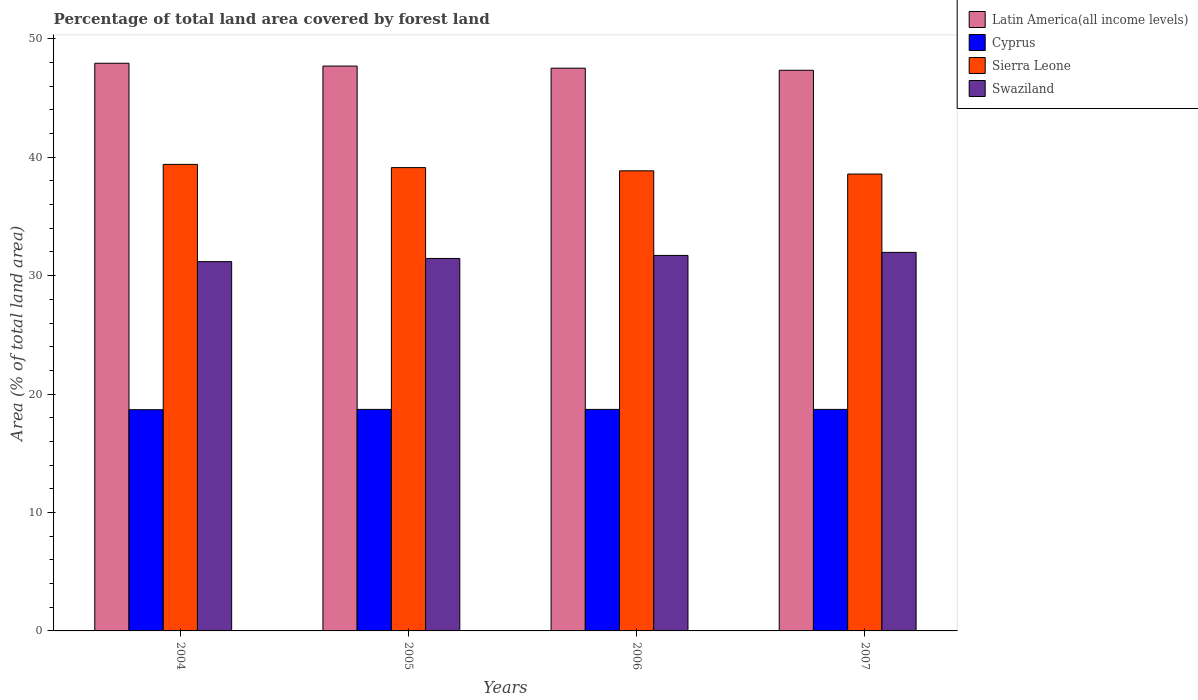How many different coloured bars are there?
Provide a short and direct response. 4. Are the number of bars per tick equal to the number of legend labels?
Ensure brevity in your answer.  Yes. What is the label of the 4th group of bars from the left?
Keep it short and to the point. 2007. In how many cases, is the number of bars for a given year not equal to the number of legend labels?
Your answer should be very brief. 0. What is the percentage of forest land in Swaziland in 2007?
Give a very brief answer. 31.97. Across all years, what is the maximum percentage of forest land in Sierra Leone?
Keep it short and to the point. 39.4. Across all years, what is the minimum percentage of forest land in Sierra Leone?
Your response must be concise. 38.58. What is the total percentage of forest land in Swaziland in the graph?
Your answer should be compact. 126.31. What is the difference between the percentage of forest land in Sierra Leone in 2005 and that in 2006?
Give a very brief answer. 0.27. What is the difference between the percentage of forest land in Sierra Leone in 2007 and the percentage of forest land in Latin America(all income levels) in 2004?
Provide a succinct answer. -9.35. What is the average percentage of forest land in Latin America(all income levels) per year?
Make the answer very short. 47.62. In the year 2005, what is the difference between the percentage of forest land in Swaziland and percentage of forest land in Latin America(all income levels)?
Provide a short and direct response. -16.24. What is the ratio of the percentage of forest land in Latin America(all income levels) in 2004 to that in 2006?
Provide a short and direct response. 1.01. Is the difference between the percentage of forest land in Swaziland in 2006 and 2007 greater than the difference between the percentage of forest land in Latin America(all income levels) in 2006 and 2007?
Provide a succinct answer. No. What is the difference between the highest and the second highest percentage of forest land in Sierra Leone?
Ensure brevity in your answer.  0.27. What is the difference between the highest and the lowest percentage of forest land in Cyprus?
Offer a very short reply. 0.03. Is the sum of the percentage of forest land in Sierra Leone in 2005 and 2007 greater than the maximum percentage of forest land in Cyprus across all years?
Give a very brief answer. Yes. What does the 3rd bar from the left in 2005 represents?
Make the answer very short. Sierra Leone. What does the 2nd bar from the right in 2007 represents?
Your answer should be very brief. Sierra Leone. How many bars are there?
Ensure brevity in your answer.  16. What is the difference between two consecutive major ticks on the Y-axis?
Offer a very short reply. 10. Are the values on the major ticks of Y-axis written in scientific E-notation?
Offer a terse response. No. Does the graph contain any zero values?
Your answer should be very brief. No. Does the graph contain grids?
Give a very brief answer. No. Where does the legend appear in the graph?
Make the answer very short. Top right. What is the title of the graph?
Offer a terse response. Percentage of total land area covered by forest land. What is the label or title of the Y-axis?
Your response must be concise. Area (% of total land area). What is the Area (% of total land area) of Latin America(all income levels) in 2004?
Your answer should be compact. 47.94. What is the Area (% of total land area) in Cyprus in 2004?
Provide a short and direct response. 18.68. What is the Area (% of total land area) of Sierra Leone in 2004?
Make the answer very short. 39.4. What is the Area (% of total land area) of Swaziland in 2004?
Provide a succinct answer. 31.19. What is the Area (% of total land area) of Latin America(all income levels) in 2005?
Make the answer very short. 47.7. What is the Area (% of total land area) of Cyprus in 2005?
Keep it short and to the point. 18.71. What is the Area (% of total land area) of Sierra Leone in 2005?
Offer a terse response. 39.12. What is the Area (% of total land area) of Swaziland in 2005?
Offer a very short reply. 31.45. What is the Area (% of total land area) of Latin America(all income levels) in 2006?
Your answer should be compact. 47.52. What is the Area (% of total land area) in Cyprus in 2006?
Provide a succinct answer. 18.71. What is the Area (% of total land area) of Sierra Leone in 2006?
Keep it short and to the point. 38.85. What is the Area (% of total land area) of Swaziland in 2006?
Your answer should be compact. 31.71. What is the Area (% of total land area) in Latin America(all income levels) in 2007?
Provide a succinct answer. 47.34. What is the Area (% of total land area) in Cyprus in 2007?
Your answer should be compact. 18.71. What is the Area (% of total land area) of Sierra Leone in 2007?
Keep it short and to the point. 38.58. What is the Area (% of total land area) of Swaziland in 2007?
Your answer should be compact. 31.97. Across all years, what is the maximum Area (% of total land area) in Latin America(all income levels)?
Make the answer very short. 47.94. Across all years, what is the maximum Area (% of total land area) of Cyprus?
Your answer should be very brief. 18.71. Across all years, what is the maximum Area (% of total land area) in Sierra Leone?
Your answer should be very brief. 39.4. Across all years, what is the maximum Area (% of total land area) in Swaziland?
Give a very brief answer. 31.97. Across all years, what is the minimum Area (% of total land area) in Latin America(all income levels)?
Your answer should be very brief. 47.34. Across all years, what is the minimum Area (% of total land area) in Cyprus?
Provide a succinct answer. 18.68. Across all years, what is the minimum Area (% of total land area) in Sierra Leone?
Your response must be concise. 38.58. Across all years, what is the minimum Area (% of total land area) of Swaziland?
Provide a short and direct response. 31.19. What is the total Area (% of total land area) of Latin America(all income levels) in the graph?
Give a very brief answer. 190.5. What is the total Area (% of total land area) in Cyprus in the graph?
Ensure brevity in your answer.  74.8. What is the total Area (% of total land area) in Sierra Leone in the graph?
Make the answer very short. 155.95. What is the total Area (% of total land area) of Swaziland in the graph?
Your answer should be very brief. 126.31. What is the difference between the Area (% of total land area) in Latin America(all income levels) in 2004 and that in 2005?
Keep it short and to the point. 0.24. What is the difference between the Area (% of total land area) in Cyprus in 2004 and that in 2005?
Your answer should be compact. -0.03. What is the difference between the Area (% of total land area) of Sierra Leone in 2004 and that in 2005?
Your answer should be very brief. 0.27. What is the difference between the Area (% of total land area) in Swaziland in 2004 and that in 2005?
Your response must be concise. -0.27. What is the difference between the Area (% of total land area) in Latin America(all income levels) in 2004 and that in 2006?
Make the answer very short. 0.42. What is the difference between the Area (% of total land area) in Cyprus in 2004 and that in 2006?
Your response must be concise. -0.03. What is the difference between the Area (% of total land area) in Sierra Leone in 2004 and that in 2006?
Provide a short and direct response. 0.54. What is the difference between the Area (% of total land area) of Swaziland in 2004 and that in 2006?
Keep it short and to the point. -0.52. What is the difference between the Area (% of total land area) of Latin America(all income levels) in 2004 and that in 2007?
Your answer should be very brief. 0.59. What is the difference between the Area (% of total land area) of Cyprus in 2004 and that in 2007?
Give a very brief answer. -0.03. What is the difference between the Area (% of total land area) in Sierra Leone in 2004 and that in 2007?
Provide a succinct answer. 0.81. What is the difference between the Area (% of total land area) in Swaziland in 2004 and that in 2007?
Provide a short and direct response. -0.78. What is the difference between the Area (% of total land area) in Latin America(all income levels) in 2005 and that in 2006?
Ensure brevity in your answer.  0.18. What is the difference between the Area (% of total land area) in Cyprus in 2005 and that in 2006?
Give a very brief answer. 0. What is the difference between the Area (% of total land area) of Sierra Leone in 2005 and that in 2006?
Offer a terse response. 0.27. What is the difference between the Area (% of total land area) in Swaziland in 2005 and that in 2006?
Offer a terse response. -0.26. What is the difference between the Area (% of total land area) in Latin America(all income levels) in 2005 and that in 2007?
Keep it short and to the point. 0.36. What is the difference between the Area (% of total land area) in Cyprus in 2005 and that in 2007?
Provide a short and direct response. 0. What is the difference between the Area (% of total land area) in Sierra Leone in 2005 and that in 2007?
Offer a very short reply. 0.54. What is the difference between the Area (% of total land area) of Swaziland in 2005 and that in 2007?
Ensure brevity in your answer.  -0.51. What is the difference between the Area (% of total land area) in Latin America(all income levels) in 2006 and that in 2007?
Provide a succinct answer. 0.18. What is the difference between the Area (% of total land area) in Cyprus in 2006 and that in 2007?
Provide a succinct answer. 0. What is the difference between the Area (% of total land area) of Sierra Leone in 2006 and that in 2007?
Your response must be concise. 0.27. What is the difference between the Area (% of total land area) in Swaziland in 2006 and that in 2007?
Offer a terse response. -0.26. What is the difference between the Area (% of total land area) of Latin America(all income levels) in 2004 and the Area (% of total land area) of Cyprus in 2005?
Provide a succinct answer. 29.23. What is the difference between the Area (% of total land area) in Latin America(all income levels) in 2004 and the Area (% of total land area) in Sierra Leone in 2005?
Your answer should be very brief. 8.81. What is the difference between the Area (% of total land area) in Latin America(all income levels) in 2004 and the Area (% of total land area) in Swaziland in 2005?
Your answer should be compact. 16.48. What is the difference between the Area (% of total land area) in Cyprus in 2004 and the Area (% of total land area) in Sierra Leone in 2005?
Offer a terse response. -20.44. What is the difference between the Area (% of total land area) of Cyprus in 2004 and the Area (% of total land area) of Swaziland in 2005?
Provide a succinct answer. -12.77. What is the difference between the Area (% of total land area) in Sierra Leone in 2004 and the Area (% of total land area) in Swaziland in 2005?
Offer a terse response. 7.94. What is the difference between the Area (% of total land area) of Latin America(all income levels) in 2004 and the Area (% of total land area) of Cyprus in 2006?
Offer a terse response. 29.23. What is the difference between the Area (% of total land area) of Latin America(all income levels) in 2004 and the Area (% of total land area) of Sierra Leone in 2006?
Provide a short and direct response. 9.08. What is the difference between the Area (% of total land area) of Latin America(all income levels) in 2004 and the Area (% of total land area) of Swaziland in 2006?
Offer a very short reply. 16.23. What is the difference between the Area (% of total land area) of Cyprus in 2004 and the Area (% of total land area) of Sierra Leone in 2006?
Your response must be concise. -20.17. What is the difference between the Area (% of total land area) of Cyprus in 2004 and the Area (% of total land area) of Swaziland in 2006?
Ensure brevity in your answer.  -13.03. What is the difference between the Area (% of total land area) in Sierra Leone in 2004 and the Area (% of total land area) in Swaziland in 2006?
Your answer should be compact. 7.69. What is the difference between the Area (% of total land area) in Latin America(all income levels) in 2004 and the Area (% of total land area) in Cyprus in 2007?
Your response must be concise. 29.23. What is the difference between the Area (% of total land area) in Latin America(all income levels) in 2004 and the Area (% of total land area) in Sierra Leone in 2007?
Your answer should be very brief. 9.35. What is the difference between the Area (% of total land area) in Latin America(all income levels) in 2004 and the Area (% of total land area) in Swaziland in 2007?
Your response must be concise. 15.97. What is the difference between the Area (% of total land area) in Cyprus in 2004 and the Area (% of total land area) in Sierra Leone in 2007?
Provide a succinct answer. -19.9. What is the difference between the Area (% of total land area) of Cyprus in 2004 and the Area (% of total land area) of Swaziland in 2007?
Your answer should be compact. -13.29. What is the difference between the Area (% of total land area) of Sierra Leone in 2004 and the Area (% of total land area) of Swaziland in 2007?
Your answer should be compact. 7.43. What is the difference between the Area (% of total land area) of Latin America(all income levels) in 2005 and the Area (% of total land area) of Cyprus in 2006?
Provide a succinct answer. 28.99. What is the difference between the Area (% of total land area) in Latin America(all income levels) in 2005 and the Area (% of total land area) in Sierra Leone in 2006?
Your answer should be very brief. 8.85. What is the difference between the Area (% of total land area) of Latin America(all income levels) in 2005 and the Area (% of total land area) of Swaziland in 2006?
Give a very brief answer. 15.99. What is the difference between the Area (% of total land area) of Cyprus in 2005 and the Area (% of total land area) of Sierra Leone in 2006?
Offer a very short reply. -20.15. What is the difference between the Area (% of total land area) of Cyprus in 2005 and the Area (% of total land area) of Swaziland in 2006?
Provide a succinct answer. -13. What is the difference between the Area (% of total land area) of Sierra Leone in 2005 and the Area (% of total land area) of Swaziland in 2006?
Provide a short and direct response. 7.42. What is the difference between the Area (% of total land area) of Latin America(all income levels) in 2005 and the Area (% of total land area) of Cyprus in 2007?
Your answer should be very brief. 28.99. What is the difference between the Area (% of total land area) of Latin America(all income levels) in 2005 and the Area (% of total land area) of Sierra Leone in 2007?
Make the answer very short. 9.12. What is the difference between the Area (% of total land area) of Latin America(all income levels) in 2005 and the Area (% of total land area) of Swaziland in 2007?
Your answer should be compact. 15.73. What is the difference between the Area (% of total land area) in Cyprus in 2005 and the Area (% of total land area) in Sierra Leone in 2007?
Make the answer very short. -19.87. What is the difference between the Area (% of total land area) of Cyprus in 2005 and the Area (% of total land area) of Swaziland in 2007?
Offer a very short reply. -13.26. What is the difference between the Area (% of total land area) in Sierra Leone in 2005 and the Area (% of total land area) in Swaziland in 2007?
Make the answer very short. 7.16. What is the difference between the Area (% of total land area) in Latin America(all income levels) in 2006 and the Area (% of total land area) in Cyprus in 2007?
Your answer should be very brief. 28.81. What is the difference between the Area (% of total land area) of Latin America(all income levels) in 2006 and the Area (% of total land area) of Sierra Leone in 2007?
Make the answer very short. 8.94. What is the difference between the Area (% of total land area) of Latin America(all income levels) in 2006 and the Area (% of total land area) of Swaziland in 2007?
Give a very brief answer. 15.56. What is the difference between the Area (% of total land area) of Cyprus in 2006 and the Area (% of total land area) of Sierra Leone in 2007?
Make the answer very short. -19.87. What is the difference between the Area (% of total land area) of Cyprus in 2006 and the Area (% of total land area) of Swaziland in 2007?
Offer a very short reply. -13.26. What is the difference between the Area (% of total land area) of Sierra Leone in 2006 and the Area (% of total land area) of Swaziland in 2007?
Keep it short and to the point. 6.89. What is the average Area (% of total land area) in Latin America(all income levels) per year?
Provide a short and direct response. 47.62. What is the average Area (% of total land area) of Cyprus per year?
Give a very brief answer. 18.7. What is the average Area (% of total land area) in Sierra Leone per year?
Keep it short and to the point. 38.99. What is the average Area (% of total land area) in Swaziland per year?
Provide a short and direct response. 31.58. In the year 2004, what is the difference between the Area (% of total land area) of Latin America(all income levels) and Area (% of total land area) of Cyprus?
Make the answer very short. 29.26. In the year 2004, what is the difference between the Area (% of total land area) in Latin America(all income levels) and Area (% of total land area) in Sierra Leone?
Your answer should be very brief. 8.54. In the year 2004, what is the difference between the Area (% of total land area) of Latin America(all income levels) and Area (% of total land area) of Swaziland?
Your answer should be very brief. 16.75. In the year 2004, what is the difference between the Area (% of total land area) of Cyprus and Area (% of total land area) of Sierra Leone?
Your answer should be compact. -20.72. In the year 2004, what is the difference between the Area (% of total land area) in Cyprus and Area (% of total land area) in Swaziland?
Your answer should be very brief. -12.51. In the year 2004, what is the difference between the Area (% of total land area) of Sierra Leone and Area (% of total land area) of Swaziland?
Provide a short and direct response. 8.21. In the year 2005, what is the difference between the Area (% of total land area) of Latin America(all income levels) and Area (% of total land area) of Cyprus?
Your answer should be very brief. 28.99. In the year 2005, what is the difference between the Area (% of total land area) of Latin America(all income levels) and Area (% of total land area) of Sierra Leone?
Offer a terse response. 8.57. In the year 2005, what is the difference between the Area (% of total land area) in Latin America(all income levels) and Area (% of total land area) in Swaziland?
Provide a succinct answer. 16.24. In the year 2005, what is the difference between the Area (% of total land area) in Cyprus and Area (% of total land area) in Sierra Leone?
Keep it short and to the point. -20.42. In the year 2005, what is the difference between the Area (% of total land area) of Cyprus and Area (% of total land area) of Swaziland?
Your response must be concise. -12.75. In the year 2005, what is the difference between the Area (% of total land area) of Sierra Leone and Area (% of total land area) of Swaziland?
Give a very brief answer. 7.67. In the year 2006, what is the difference between the Area (% of total land area) of Latin America(all income levels) and Area (% of total land area) of Cyprus?
Your answer should be very brief. 28.81. In the year 2006, what is the difference between the Area (% of total land area) of Latin America(all income levels) and Area (% of total land area) of Sierra Leone?
Make the answer very short. 8.67. In the year 2006, what is the difference between the Area (% of total land area) of Latin America(all income levels) and Area (% of total land area) of Swaziland?
Keep it short and to the point. 15.81. In the year 2006, what is the difference between the Area (% of total land area) in Cyprus and Area (% of total land area) in Sierra Leone?
Your answer should be compact. -20.15. In the year 2006, what is the difference between the Area (% of total land area) of Cyprus and Area (% of total land area) of Swaziland?
Ensure brevity in your answer.  -13. In the year 2006, what is the difference between the Area (% of total land area) in Sierra Leone and Area (% of total land area) in Swaziland?
Offer a terse response. 7.14. In the year 2007, what is the difference between the Area (% of total land area) of Latin America(all income levels) and Area (% of total land area) of Cyprus?
Provide a short and direct response. 28.64. In the year 2007, what is the difference between the Area (% of total land area) in Latin America(all income levels) and Area (% of total land area) in Sierra Leone?
Your answer should be compact. 8.76. In the year 2007, what is the difference between the Area (% of total land area) of Latin America(all income levels) and Area (% of total land area) of Swaziland?
Offer a very short reply. 15.38. In the year 2007, what is the difference between the Area (% of total land area) of Cyprus and Area (% of total land area) of Sierra Leone?
Ensure brevity in your answer.  -19.87. In the year 2007, what is the difference between the Area (% of total land area) in Cyprus and Area (% of total land area) in Swaziland?
Offer a very short reply. -13.26. In the year 2007, what is the difference between the Area (% of total land area) in Sierra Leone and Area (% of total land area) in Swaziland?
Keep it short and to the point. 6.62. What is the ratio of the Area (% of total land area) of Cyprus in 2004 to that in 2005?
Provide a succinct answer. 1. What is the ratio of the Area (% of total land area) in Sierra Leone in 2004 to that in 2005?
Offer a very short reply. 1.01. What is the ratio of the Area (% of total land area) in Swaziland in 2004 to that in 2005?
Provide a short and direct response. 0.99. What is the ratio of the Area (% of total land area) in Latin America(all income levels) in 2004 to that in 2006?
Keep it short and to the point. 1.01. What is the ratio of the Area (% of total land area) of Cyprus in 2004 to that in 2006?
Offer a very short reply. 1. What is the ratio of the Area (% of total land area) in Sierra Leone in 2004 to that in 2006?
Your answer should be compact. 1.01. What is the ratio of the Area (% of total land area) in Swaziland in 2004 to that in 2006?
Provide a succinct answer. 0.98. What is the ratio of the Area (% of total land area) of Latin America(all income levels) in 2004 to that in 2007?
Keep it short and to the point. 1.01. What is the ratio of the Area (% of total land area) of Sierra Leone in 2004 to that in 2007?
Provide a succinct answer. 1.02. What is the ratio of the Area (% of total land area) in Swaziland in 2004 to that in 2007?
Give a very brief answer. 0.98. What is the ratio of the Area (% of total land area) in Latin America(all income levels) in 2005 to that in 2007?
Make the answer very short. 1.01. What is the ratio of the Area (% of total land area) in Cyprus in 2005 to that in 2007?
Give a very brief answer. 1. What is the ratio of the Area (% of total land area) of Sierra Leone in 2005 to that in 2007?
Make the answer very short. 1.01. What is the ratio of the Area (% of total land area) in Swaziland in 2005 to that in 2007?
Keep it short and to the point. 0.98. What is the ratio of the Area (% of total land area) of Latin America(all income levels) in 2006 to that in 2007?
Provide a short and direct response. 1. What is the ratio of the Area (% of total land area) in Cyprus in 2006 to that in 2007?
Your response must be concise. 1. What is the ratio of the Area (% of total land area) of Sierra Leone in 2006 to that in 2007?
Provide a short and direct response. 1.01. What is the ratio of the Area (% of total land area) of Swaziland in 2006 to that in 2007?
Keep it short and to the point. 0.99. What is the difference between the highest and the second highest Area (% of total land area) of Latin America(all income levels)?
Offer a terse response. 0.24. What is the difference between the highest and the second highest Area (% of total land area) in Cyprus?
Provide a succinct answer. 0. What is the difference between the highest and the second highest Area (% of total land area) of Sierra Leone?
Give a very brief answer. 0.27. What is the difference between the highest and the second highest Area (% of total land area) of Swaziland?
Provide a short and direct response. 0.26. What is the difference between the highest and the lowest Area (% of total land area) of Latin America(all income levels)?
Make the answer very short. 0.59. What is the difference between the highest and the lowest Area (% of total land area) in Cyprus?
Provide a succinct answer. 0.03. What is the difference between the highest and the lowest Area (% of total land area) of Sierra Leone?
Your answer should be compact. 0.81. What is the difference between the highest and the lowest Area (% of total land area) in Swaziland?
Keep it short and to the point. 0.78. 